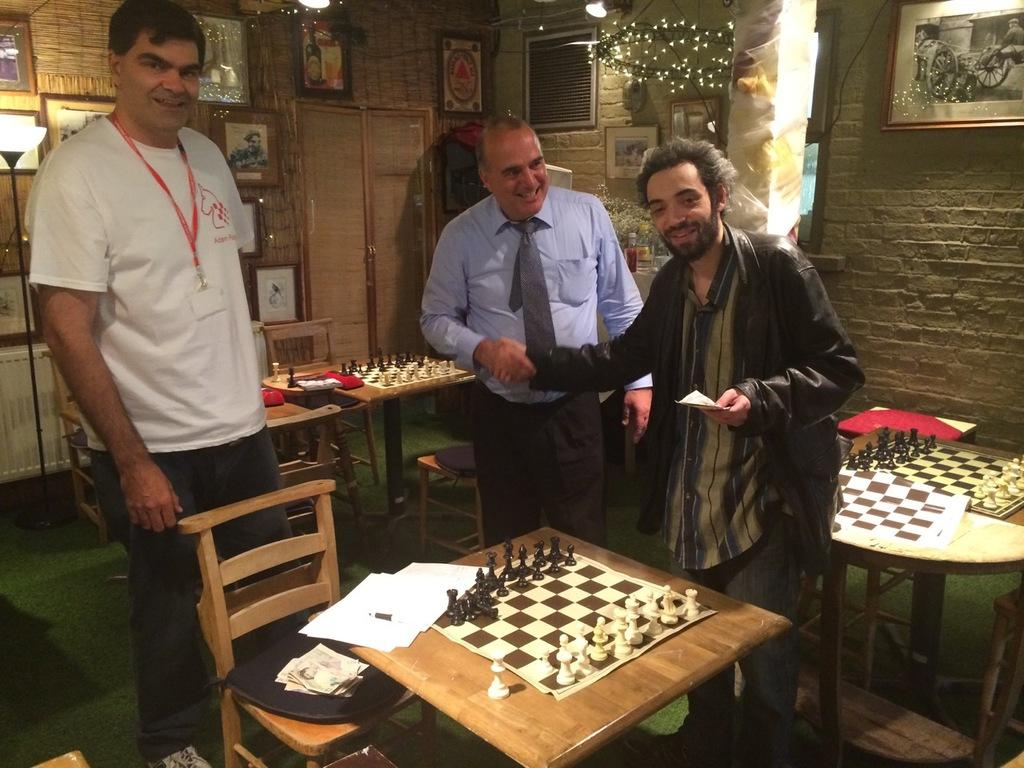What is happening in the room in the image? There are men standing in the room. What objects are present in the room? There are tables in the room. What activity are the men likely engaged in? The tables have chess boards on them, so the men are likely playing chess. Can you describe anything on the wall in the image? There is a photo frame behind the wall. What type of lunchroom is depicted in the image? There is no lunchroom present in the image; it features a room with men playing chess. Can you tell me what color cap one of the men is wearing in the image? There is no cap visible on any of the men in the image. 